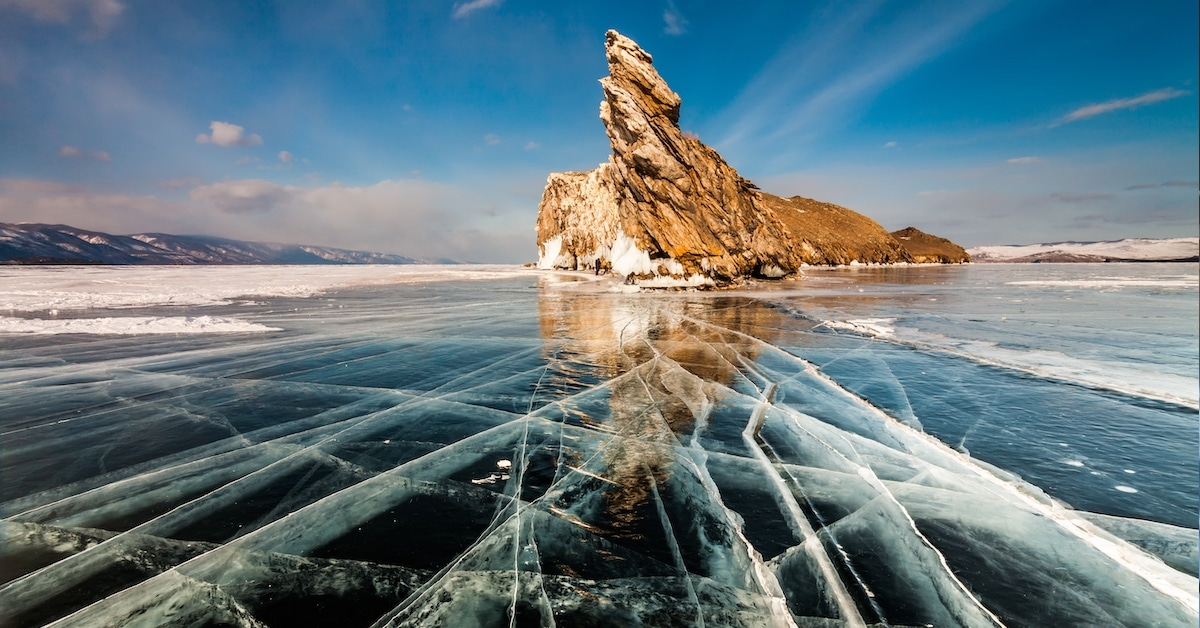Write a detailed description of the given image. This image showcases the majestic Lake Baikal, renowned for being the deepest and one of the oldest lakes in the world. The perspective is captured from the lake’s icy surface, showcasing the transparent blue ice with intricate patterns visible beneath the surface, which is a phenomenon only observed in this unique geographic location. The center of the frame is dominated by a striking rock formation, resembling a colossal brown and white monument against the clear sky, its peak lightly dusted with snow. The wide-angle shot also captures the expansive view of the distant snow-covered hills and a barely cloud-dotted azure sky, with the sun casting a radiant light that highlights the icy texture and the rock's rugged surface. The image is a celebration of natural colors, predominantly blue, white, and brown, which together create a calm yet awe-inspiring scenery. In addition to its beauty, Lake Baikal holds substantial scientific interest due to its biodiversity and the unique natural processes occurring in and around it. 